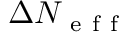Convert formula to latex. <formula><loc_0><loc_0><loc_500><loc_500>\Delta N _ { e f f }</formula> 